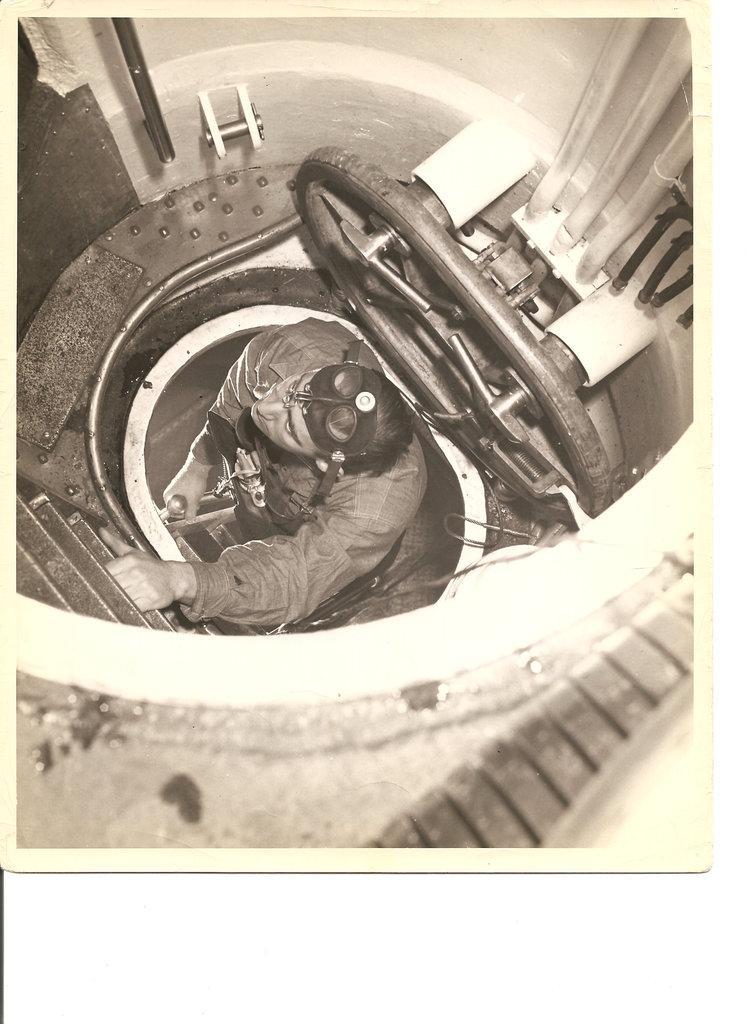Can you describe this image briefly? In this image we can see there is a person climbing a ladder. And the object looks like a tunnel. 